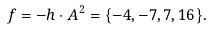Convert formula to latex. <formula><loc_0><loc_0><loc_500><loc_500>f = - h \cdot A ^ { 2 } = \{ - 4 , - 7 , 7 , 1 6 \} .</formula> 